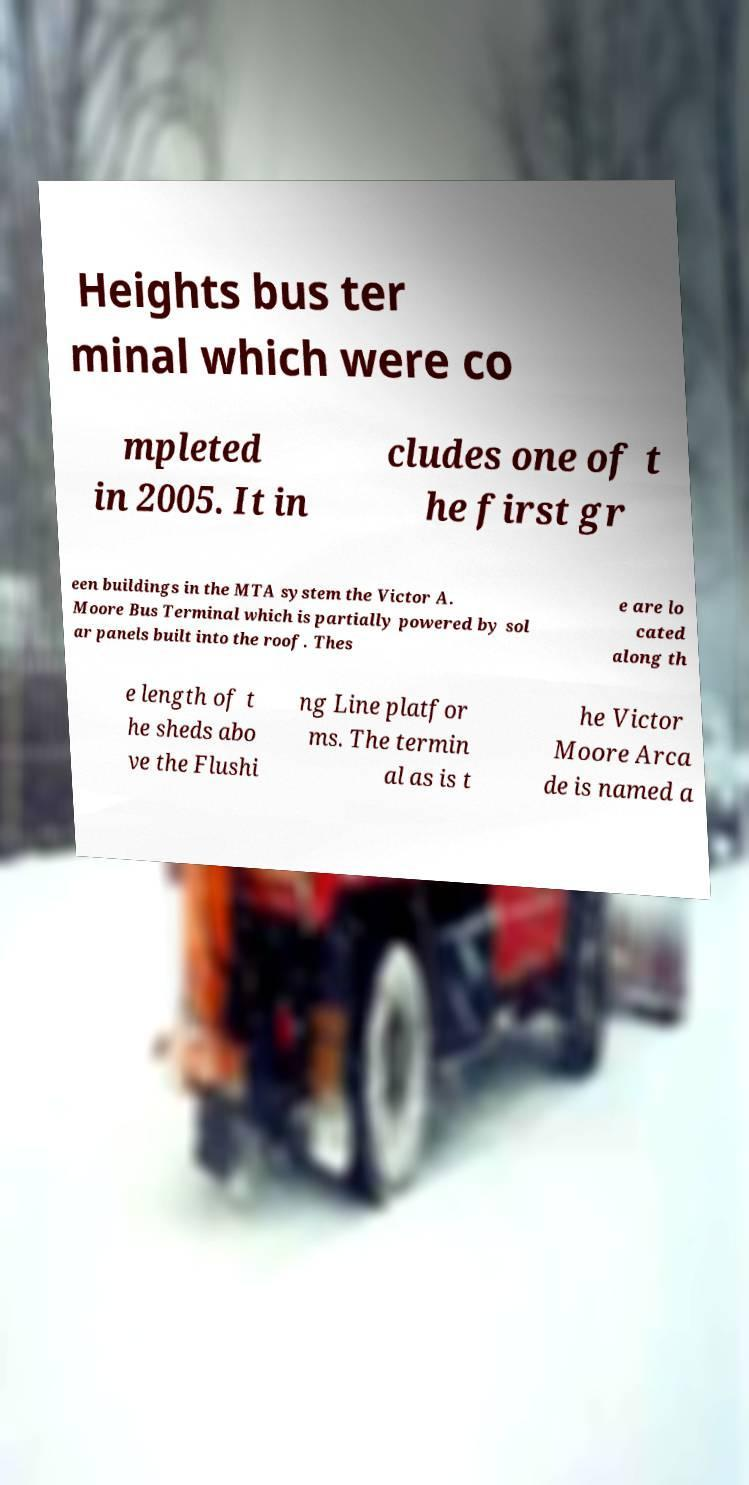Please identify and transcribe the text found in this image. Heights bus ter minal which were co mpleted in 2005. It in cludes one of t he first gr een buildings in the MTA system the Victor A. Moore Bus Terminal which is partially powered by sol ar panels built into the roof. Thes e are lo cated along th e length of t he sheds abo ve the Flushi ng Line platfor ms. The termin al as is t he Victor Moore Arca de is named a 